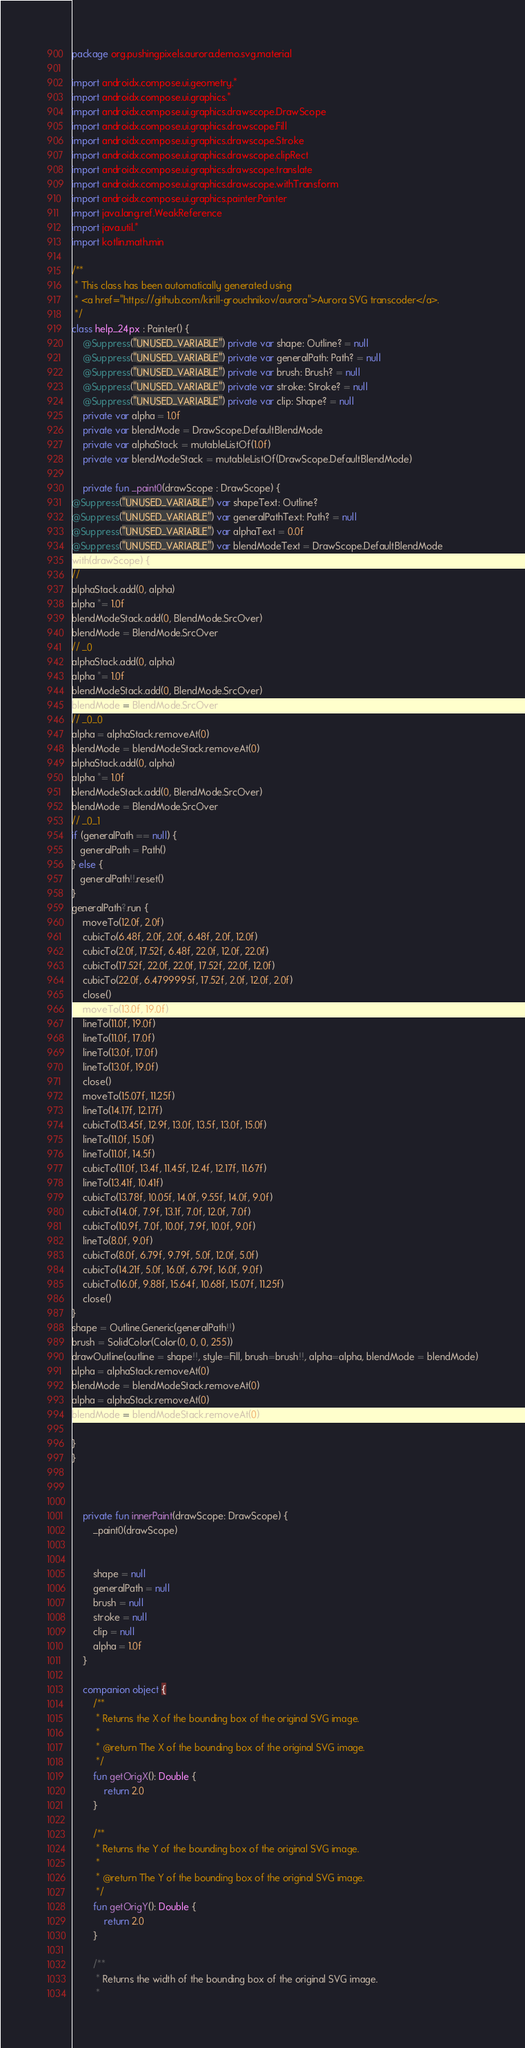Convert code to text. <code><loc_0><loc_0><loc_500><loc_500><_Kotlin_>package org.pushingpixels.aurora.demo.svg.material

import androidx.compose.ui.geometry.*
import androidx.compose.ui.graphics.*
import androidx.compose.ui.graphics.drawscope.DrawScope
import androidx.compose.ui.graphics.drawscope.Fill
import androidx.compose.ui.graphics.drawscope.Stroke
import androidx.compose.ui.graphics.drawscope.clipRect
import androidx.compose.ui.graphics.drawscope.translate
import androidx.compose.ui.graphics.drawscope.withTransform
import androidx.compose.ui.graphics.painter.Painter
import java.lang.ref.WeakReference
import java.util.*
import kotlin.math.min

/**
 * This class has been automatically generated using
 * <a href="https://github.com/kirill-grouchnikov/aurora">Aurora SVG transcoder</a>.
 */
class help_24px : Painter() {
    @Suppress("UNUSED_VARIABLE") private var shape: Outline? = null
    @Suppress("UNUSED_VARIABLE") private var generalPath: Path? = null
    @Suppress("UNUSED_VARIABLE") private var brush: Brush? = null
    @Suppress("UNUSED_VARIABLE") private var stroke: Stroke? = null
    @Suppress("UNUSED_VARIABLE") private var clip: Shape? = null
    private var alpha = 1.0f
    private var blendMode = DrawScope.DefaultBlendMode
    private var alphaStack = mutableListOf(1.0f)
    private var blendModeStack = mutableListOf(DrawScope.DefaultBlendMode)

	private fun _paint0(drawScope : DrawScope) {
@Suppress("UNUSED_VARIABLE") var shapeText: Outline?
@Suppress("UNUSED_VARIABLE") var generalPathText: Path? = null
@Suppress("UNUSED_VARIABLE") var alphaText = 0.0f
@Suppress("UNUSED_VARIABLE") var blendModeText = DrawScope.DefaultBlendMode
with(drawScope) {
// 
alphaStack.add(0, alpha)
alpha *= 1.0f
blendModeStack.add(0, BlendMode.SrcOver)
blendMode = BlendMode.SrcOver
// _0
alphaStack.add(0, alpha)
alpha *= 1.0f
blendModeStack.add(0, BlendMode.SrcOver)
blendMode = BlendMode.SrcOver
// _0_0
alpha = alphaStack.removeAt(0)
blendMode = blendModeStack.removeAt(0)
alphaStack.add(0, alpha)
alpha *= 1.0f
blendModeStack.add(0, BlendMode.SrcOver)
blendMode = BlendMode.SrcOver
// _0_1
if (generalPath == null) {
   generalPath = Path()
} else {
   generalPath!!.reset()
}
generalPath?.run {
    moveTo(12.0f, 2.0f)
    cubicTo(6.48f, 2.0f, 2.0f, 6.48f, 2.0f, 12.0f)
    cubicTo(2.0f, 17.52f, 6.48f, 22.0f, 12.0f, 22.0f)
    cubicTo(17.52f, 22.0f, 22.0f, 17.52f, 22.0f, 12.0f)
    cubicTo(22.0f, 6.4799995f, 17.52f, 2.0f, 12.0f, 2.0f)
    close()
    moveTo(13.0f, 19.0f)
    lineTo(11.0f, 19.0f)
    lineTo(11.0f, 17.0f)
    lineTo(13.0f, 17.0f)
    lineTo(13.0f, 19.0f)
    close()
    moveTo(15.07f, 11.25f)
    lineTo(14.17f, 12.17f)
    cubicTo(13.45f, 12.9f, 13.0f, 13.5f, 13.0f, 15.0f)
    lineTo(11.0f, 15.0f)
    lineTo(11.0f, 14.5f)
    cubicTo(11.0f, 13.4f, 11.45f, 12.4f, 12.17f, 11.67f)
    lineTo(13.41f, 10.41f)
    cubicTo(13.78f, 10.05f, 14.0f, 9.55f, 14.0f, 9.0f)
    cubicTo(14.0f, 7.9f, 13.1f, 7.0f, 12.0f, 7.0f)
    cubicTo(10.9f, 7.0f, 10.0f, 7.9f, 10.0f, 9.0f)
    lineTo(8.0f, 9.0f)
    cubicTo(8.0f, 6.79f, 9.79f, 5.0f, 12.0f, 5.0f)
    cubicTo(14.21f, 5.0f, 16.0f, 6.79f, 16.0f, 9.0f)
    cubicTo(16.0f, 9.88f, 15.64f, 10.68f, 15.07f, 11.25f)
    close()
}
shape = Outline.Generic(generalPath!!)
brush = SolidColor(Color(0, 0, 0, 255))
drawOutline(outline = shape!!, style=Fill, brush=brush!!, alpha=alpha, blendMode = blendMode)
alpha = alphaStack.removeAt(0)
blendMode = blendModeStack.removeAt(0)
alpha = alphaStack.removeAt(0)
blendMode = blendModeStack.removeAt(0)

}
}



    private fun innerPaint(drawScope: DrawScope) {
	    _paint0(drawScope)


	    shape = null
	    generalPath = null
	    brush = null
	    stroke = null
	    clip = null
	    alpha = 1.0f
	}
	
    companion object {
        /**
         * Returns the X of the bounding box of the original SVG image.
         *
         * @return The X of the bounding box of the original SVG image.
         */
        fun getOrigX(): Double {
            return 2.0
        }

        /**
         * Returns the Y of the bounding box of the original SVG image.
         *
         * @return The Y of the bounding box of the original SVG image.
         */
        fun getOrigY(): Double {
            return 2.0
        }

        /**
         * Returns the width of the bounding box of the original SVG image.
         *</code> 